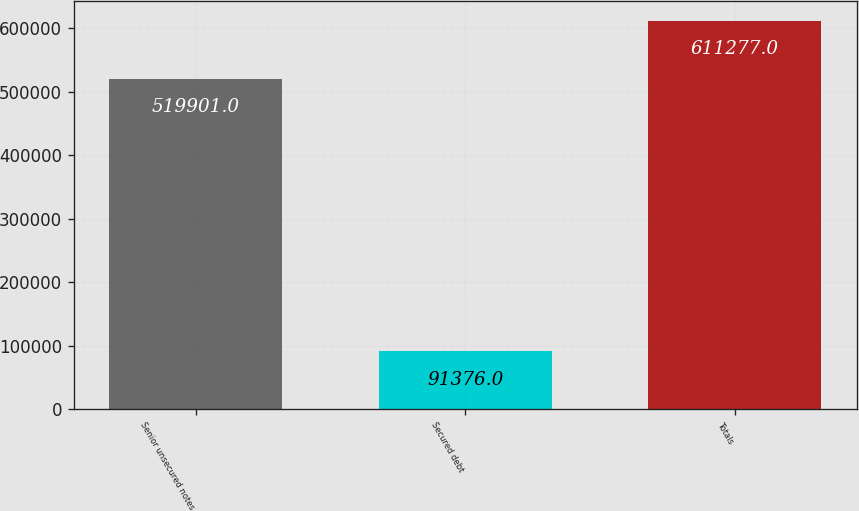Convert chart. <chart><loc_0><loc_0><loc_500><loc_500><bar_chart><fcel>Senior unsecured notes<fcel>Secured debt<fcel>Totals<nl><fcel>519901<fcel>91376<fcel>611277<nl></chart> 